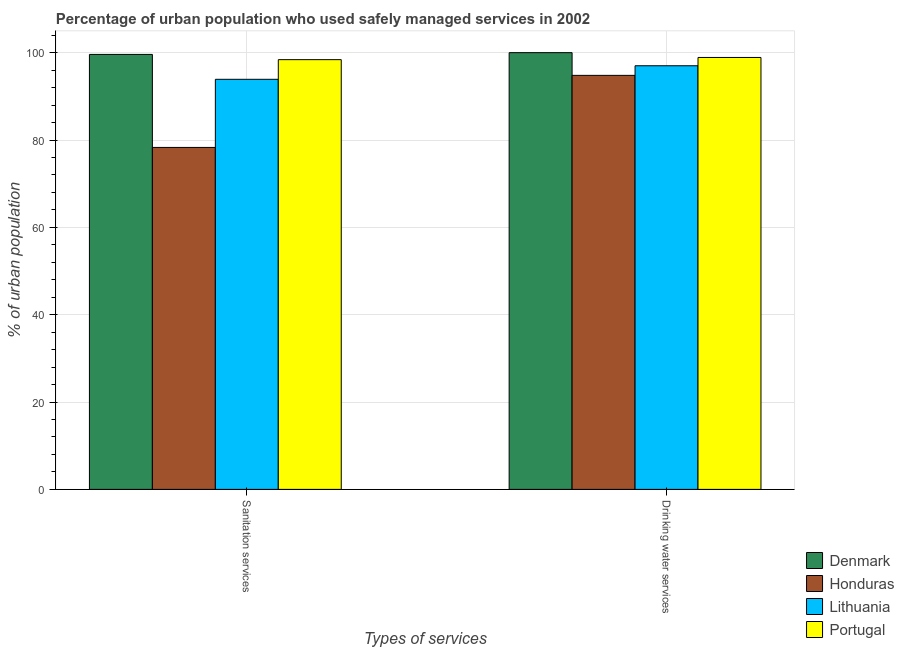Are the number of bars per tick equal to the number of legend labels?
Your answer should be compact. Yes. Are the number of bars on each tick of the X-axis equal?
Keep it short and to the point. Yes. How many bars are there on the 2nd tick from the left?
Ensure brevity in your answer.  4. How many bars are there on the 1st tick from the right?
Offer a terse response. 4. What is the label of the 1st group of bars from the left?
Provide a succinct answer. Sanitation services. What is the percentage of urban population who used drinking water services in Lithuania?
Your answer should be compact. 97. Across all countries, what is the minimum percentage of urban population who used sanitation services?
Ensure brevity in your answer.  78.3. In which country was the percentage of urban population who used sanitation services maximum?
Keep it short and to the point. Denmark. In which country was the percentage of urban population who used drinking water services minimum?
Offer a very short reply. Honduras. What is the total percentage of urban population who used sanitation services in the graph?
Your response must be concise. 370.2. What is the difference between the percentage of urban population who used sanitation services in Lithuania and that in Denmark?
Offer a terse response. -5.7. What is the difference between the percentage of urban population who used drinking water services in Denmark and the percentage of urban population who used sanitation services in Portugal?
Provide a short and direct response. 1.6. What is the average percentage of urban population who used drinking water services per country?
Make the answer very short. 97.68. What is the difference between the percentage of urban population who used drinking water services and percentage of urban population who used sanitation services in Denmark?
Your answer should be very brief. 0.4. What is the ratio of the percentage of urban population who used drinking water services in Honduras to that in Denmark?
Your answer should be very brief. 0.95. In how many countries, is the percentage of urban population who used sanitation services greater than the average percentage of urban population who used sanitation services taken over all countries?
Your answer should be compact. 3. What does the 3rd bar from the left in Drinking water services represents?
Your answer should be compact. Lithuania. What does the 3rd bar from the right in Drinking water services represents?
Offer a terse response. Honduras. Are the values on the major ticks of Y-axis written in scientific E-notation?
Ensure brevity in your answer.  No. Does the graph contain any zero values?
Offer a very short reply. No. Does the graph contain grids?
Your answer should be compact. Yes. Where does the legend appear in the graph?
Ensure brevity in your answer.  Bottom right. How many legend labels are there?
Your answer should be compact. 4. How are the legend labels stacked?
Offer a very short reply. Vertical. What is the title of the graph?
Keep it short and to the point. Percentage of urban population who used safely managed services in 2002. Does "High income" appear as one of the legend labels in the graph?
Provide a short and direct response. No. What is the label or title of the X-axis?
Give a very brief answer. Types of services. What is the label or title of the Y-axis?
Your answer should be very brief. % of urban population. What is the % of urban population in Denmark in Sanitation services?
Your answer should be very brief. 99.6. What is the % of urban population of Honduras in Sanitation services?
Your answer should be very brief. 78.3. What is the % of urban population of Lithuania in Sanitation services?
Your answer should be compact. 93.9. What is the % of urban population of Portugal in Sanitation services?
Provide a succinct answer. 98.4. What is the % of urban population in Honduras in Drinking water services?
Your response must be concise. 94.8. What is the % of urban population in Lithuania in Drinking water services?
Offer a terse response. 97. What is the % of urban population in Portugal in Drinking water services?
Ensure brevity in your answer.  98.9. Across all Types of services, what is the maximum % of urban population of Denmark?
Keep it short and to the point. 100. Across all Types of services, what is the maximum % of urban population in Honduras?
Provide a short and direct response. 94.8. Across all Types of services, what is the maximum % of urban population in Lithuania?
Give a very brief answer. 97. Across all Types of services, what is the maximum % of urban population in Portugal?
Offer a terse response. 98.9. Across all Types of services, what is the minimum % of urban population of Denmark?
Keep it short and to the point. 99.6. Across all Types of services, what is the minimum % of urban population of Honduras?
Give a very brief answer. 78.3. Across all Types of services, what is the minimum % of urban population of Lithuania?
Provide a short and direct response. 93.9. Across all Types of services, what is the minimum % of urban population of Portugal?
Ensure brevity in your answer.  98.4. What is the total % of urban population in Denmark in the graph?
Make the answer very short. 199.6. What is the total % of urban population of Honduras in the graph?
Ensure brevity in your answer.  173.1. What is the total % of urban population of Lithuania in the graph?
Provide a succinct answer. 190.9. What is the total % of urban population of Portugal in the graph?
Offer a very short reply. 197.3. What is the difference between the % of urban population of Denmark in Sanitation services and that in Drinking water services?
Make the answer very short. -0.4. What is the difference between the % of urban population in Honduras in Sanitation services and that in Drinking water services?
Your answer should be compact. -16.5. What is the difference between the % of urban population of Portugal in Sanitation services and that in Drinking water services?
Your answer should be compact. -0.5. What is the difference between the % of urban population in Denmark in Sanitation services and the % of urban population in Honduras in Drinking water services?
Your response must be concise. 4.8. What is the difference between the % of urban population of Denmark in Sanitation services and the % of urban population of Portugal in Drinking water services?
Provide a short and direct response. 0.7. What is the difference between the % of urban population of Honduras in Sanitation services and the % of urban population of Lithuania in Drinking water services?
Provide a succinct answer. -18.7. What is the difference between the % of urban population of Honduras in Sanitation services and the % of urban population of Portugal in Drinking water services?
Your answer should be compact. -20.6. What is the difference between the % of urban population of Lithuania in Sanitation services and the % of urban population of Portugal in Drinking water services?
Offer a terse response. -5. What is the average % of urban population in Denmark per Types of services?
Your answer should be compact. 99.8. What is the average % of urban population of Honduras per Types of services?
Offer a terse response. 86.55. What is the average % of urban population in Lithuania per Types of services?
Your answer should be very brief. 95.45. What is the average % of urban population in Portugal per Types of services?
Your answer should be compact. 98.65. What is the difference between the % of urban population of Denmark and % of urban population of Honduras in Sanitation services?
Keep it short and to the point. 21.3. What is the difference between the % of urban population in Denmark and % of urban population in Lithuania in Sanitation services?
Provide a short and direct response. 5.7. What is the difference between the % of urban population of Honduras and % of urban population of Lithuania in Sanitation services?
Your response must be concise. -15.6. What is the difference between the % of urban population in Honduras and % of urban population in Portugal in Sanitation services?
Your answer should be compact. -20.1. What is the difference between the % of urban population in Lithuania and % of urban population in Portugal in Sanitation services?
Keep it short and to the point. -4.5. What is the difference between the % of urban population in Denmark and % of urban population in Lithuania in Drinking water services?
Your response must be concise. 3. What is the difference between the % of urban population in Denmark and % of urban population in Portugal in Drinking water services?
Offer a terse response. 1.1. What is the difference between the % of urban population of Honduras and % of urban population of Lithuania in Drinking water services?
Offer a very short reply. -2.2. What is the ratio of the % of urban population of Honduras in Sanitation services to that in Drinking water services?
Keep it short and to the point. 0.83. What is the difference between the highest and the second highest % of urban population in Denmark?
Provide a succinct answer. 0.4. What is the difference between the highest and the second highest % of urban population in Honduras?
Offer a terse response. 16.5. 